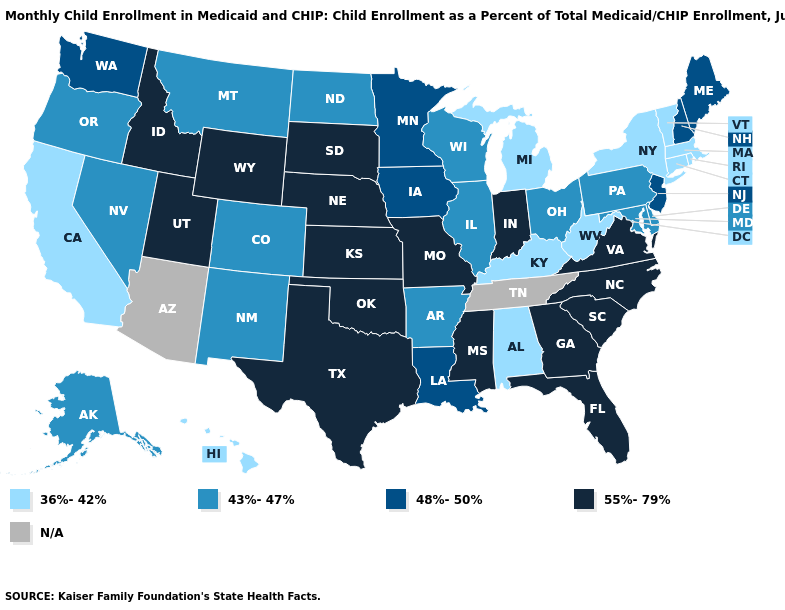Which states have the lowest value in the MidWest?
Write a very short answer. Michigan. Does Vermont have the highest value in the Northeast?
Write a very short answer. No. What is the value of South Dakota?
Short answer required. 55%-79%. Which states hav the highest value in the South?
Answer briefly. Florida, Georgia, Mississippi, North Carolina, Oklahoma, South Carolina, Texas, Virginia. Does the first symbol in the legend represent the smallest category?
Keep it brief. Yes. What is the value of Florida?
Quick response, please. 55%-79%. What is the value of Michigan?
Concise answer only. 36%-42%. Among the states that border New Mexico , does Colorado have the highest value?
Quick response, please. No. Among the states that border Kansas , does Missouri have the highest value?
Short answer required. Yes. Which states hav the highest value in the South?
Write a very short answer. Florida, Georgia, Mississippi, North Carolina, Oklahoma, South Carolina, Texas, Virginia. What is the highest value in states that border Connecticut?
Answer briefly. 36%-42%. Does the first symbol in the legend represent the smallest category?
Write a very short answer. Yes. What is the value of West Virginia?
Answer briefly. 36%-42%. Name the states that have a value in the range 55%-79%?
Write a very short answer. Florida, Georgia, Idaho, Indiana, Kansas, Mississippi, Missouri, Nebraska, North Carolina, Oklahoma, South Carolina, South Dakota, Texas, Utah, Virginia, Wyoming. 